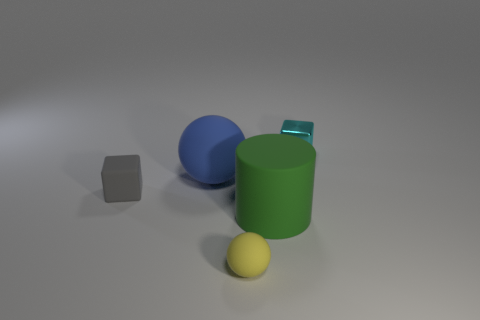Add 1 large green shiny things. How many objects exist? 6 Subtract all cylinders. Subtract all small cyan objects. How many objects are left? 3 Add 1 big green matte cylinders. How many big green matte cylinders are left? 2 Add 3 yellow spheres. How many yellow spheres exist? 4 Subtract 1 yellow balls. How many objects are left? 4 Subtract all spheres. How many objects are left? 3 